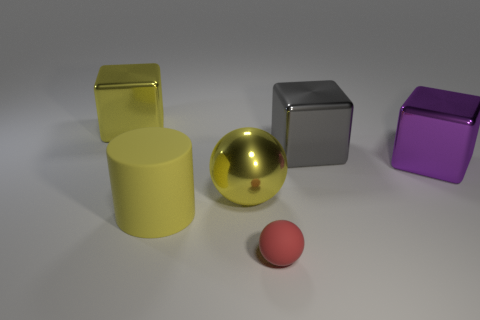Add 2 big purple metal balls. How many objects exist? 8 Subtract all cylinders. How many objects are left? 5 Subtract all large spheres. Subtract all small blue shiny balls. How many objects are left? 5 Add 5 small matte things. How many small matte things are left? 6 Add 2 tiny spheres. How many tiny spheres exist? 3 Subtract 1 purple blocks. How many objects are left? 5 